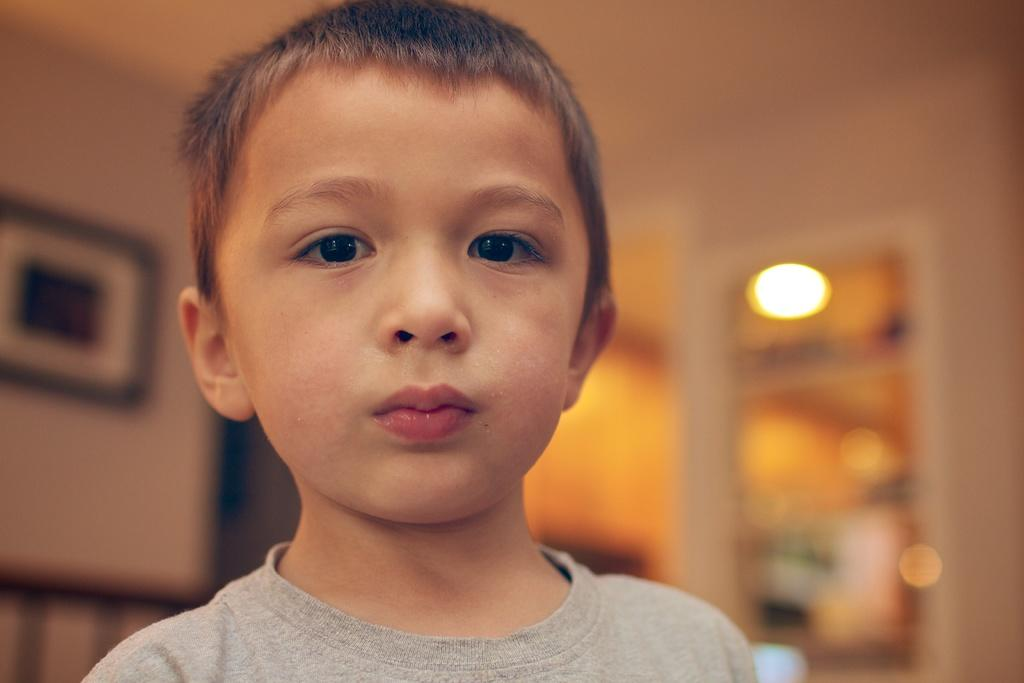Who is the main subject in the image? There is a boy in the image. What object can be seen on the left side of the image? There is a photo frame on the left side of the image. How is the photo frame positioned in the image? The photo frame is attached to the wall. Can you describe the background of the image? The background of the image appears blurry. What type of kettle is visible in the image? There is no kettle present in the image. What shape is the photo frame in the image? The shape of the photo frame is not mentioned in the provided facts, so we cannot determine its shape from the image. 